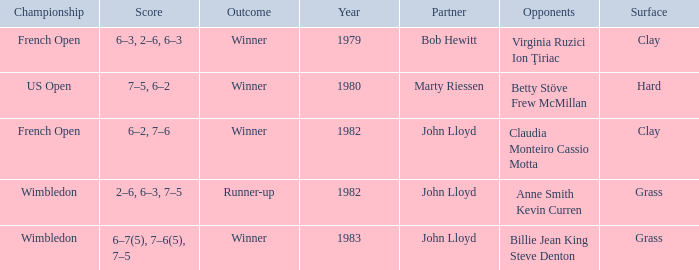What was the total number of matches that had an outcome of Winner, a partner of John Lloyd, and a clay surface? 1.0. Give me the full table as a dictionary. {'header': ['Championship', 'Score', 'Outcome', 'Year', 'Partner', 'Opponents', 'Surface'], 'rows': [['French Open', '6–3, 2–6, 6–3', 'Winner', '1979', 'Bob Hewitt', 'Virginia Ruzici Ion Ţiriac', 'Clay'], ['US Open', '7–5, 6–2', 'Winner', '1980', 'Marty Riessen', 'Betty Stöve Frew McMillan', 'Hard'], ['French Open', '6–2, 7–6', 'Winner', '1982', 'John Lloyd', 'Claudia Monteiro Cassio Motta', 'Clay'], ['Wimbledon', '2–6, 6–3, 7–5', 'Runner-up', '1982', 'John Lloyd', 'Anne Smith Kevin Curren', 'Grass'], ['Wimbledon', '6–7(5), 7–6(5), 7–5', 'Winner', '1983', 'John Lloyd', 'Billie Jean King Steve Denton', 'Grass']]} 